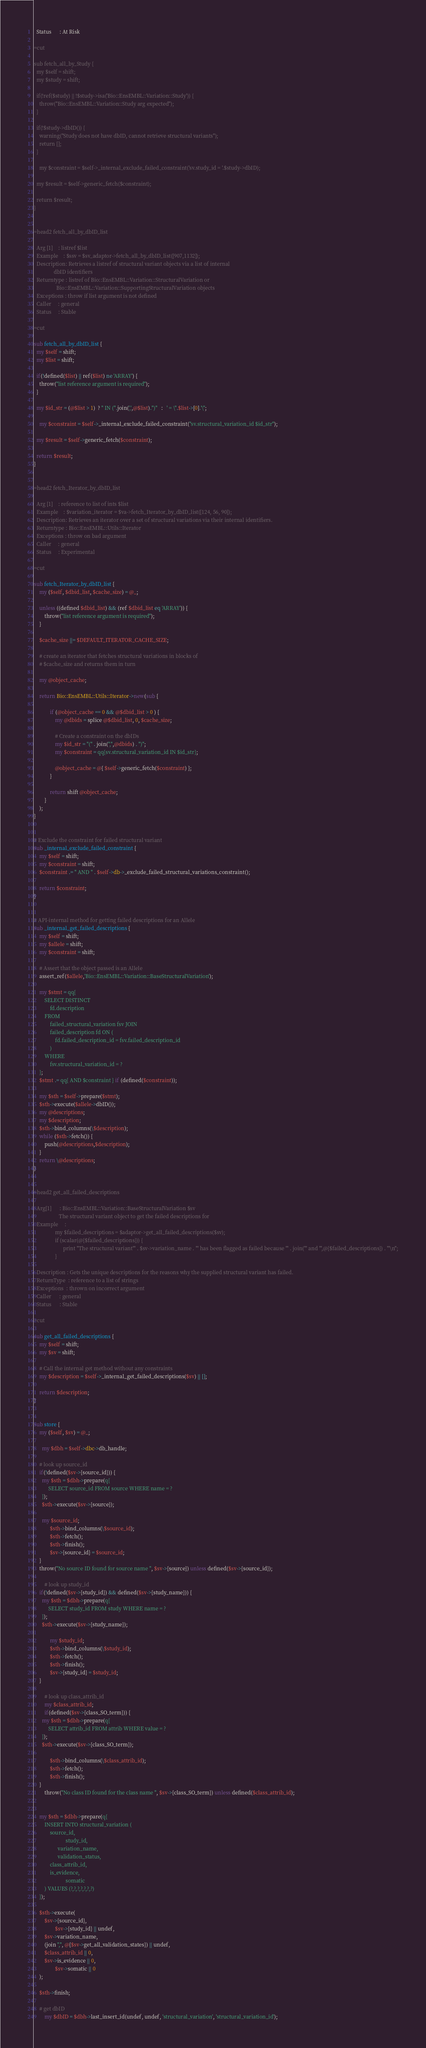Convert code to text. <code><loc_0><loc_0><loc_500><loc_500><_Perl_>  Status      : At Risk

=cut

sub fetch_all_by_Study {
  my $self = shift;
  my $study = shift;

  if(!ref($study) || !$study->isa('Bio::EnsEMBL::Variation::Study')) {
    throw("Bio::EnsEMBL::Variation::Study arg expected");
  }
    
  if(!$study->dbID()) {
    warning("Study does not have dbID, cannot retrieve structural variants");
    return [];
  } 
	
	my $constraint = $self->_internal_exclude_failed_constraint('sv.study_id = '.$study->dbID);
	
  my $result = $self->generic_fetch($constraint);

  return $result;
}


=head2 fetch_all_by_dbID_list

  Arg [1]    : listref $list
  Example    : $ssv = $sv_adaptor->fetch_all_by_dbID_list([907,1132]);
  Description: Retrieves a listref of structural variant objects via a list of internal
               dbID identifiers
  Returntype : listref of Bio::EnsEMBL::Variation::StructuralVariation or
	             Bio::EnsEMBL::Variation::SupportingStructuralVariation objects
  Exceptions : throw if list argument is not defined
  Caller     : general
  Status     : Stable

=cut

sub fetch_all_by_dbID_list {
  my $self = shift;
  my $list = shift;

  if(!defined($list) || ref($list) ne 'ARRAY') {
    throw("list reference argument is required");
  }
  
  my $id_str = (@$list > 1)  ? " IN (".join(',',@$list).")"   :   ' = \''.$list->[0].'\'';
	
	my $constraint = $self->_internal_exclude_failed_constraint("sv.structural_variation_id $id_str");
	
  my $result = $self->generic_fetch($constraint);

  return $result;
}


=head2 fetch_Iterator_by_dbID_list

  Arg [1]    : reference to list of ints $list
  Example    : $variation_iterator = $va->fetch_Iterator_by_dbID_list([124, 56, 90]);
  Description: Retrieves an iterator over a set of structural variations via their internal identifiers.
  Returntype : Bio::EnsEMBL::Utils::Iterator
  Exceptions : throw on bad argument
  Caller     : general
  Status     : Experimental

=cut

sub fetch_Iterator_by_dbID_list {
    my ($self, $dbid_list, $cache_size) = @_;
    
    unless ((defined $dbid_list) && (ref $dbid_list eq 'ARRAY')) {
        throw("list reference argument is required");
    }

    $cache_size ||= $DEFAULT_ITERATOR_CACHE_SIZE;

    # create an iterator that fetches structural variations in blocks of
    # $cache_size and returns them in turn

    my @object_cache;

    return Bio::EnsEMBL::Utils::Iterator->new(sub {

            if (@object_cache == 0 && @$dbid_list > 0 ) {
                my @dbids = splice @$dbid_list, 0, $cache_size;
                
                # Create a constraint on the dbIDs
                my $id_str = "(" . join(",",@dbids) . ")";
                my $constraint = qq{sv.structural_variation_id IN $id_str};
                
                @object_cache = @{ $self->generic_fetch($constraint) };
            }

            return shift @object_cache;
        }
    );
}


# Exclude the constraint for failed structural variant
sub _internal_exclude_failed_constraint {
	my $self = shift;
	my $constraint = shift;
	$constraint .= " AND " . $self->db->_exclude_failed_structural_variations_constraint();
	
	return $constraint;
}


# API-internal method for getting failed descriptions for an Allele
sub _internal_get_failed_descriptions {
    my $self = shift;
    my $allele = shift;
    my $constraint = shift;
    
    # Assert that the object passed is an Allele
    assert_ref($allele,'Bio::EnsEMBL::Variation::BaseStructuralVariation');
    
    my $stmt = qq{
        SELECT DISTINCT
            fd.description
        FROM
            failed_structural_variation fsv JOIN
            failed_description fd ON (
                fd.failed_description_id = fsv.failed_description_id
            )
        WHERE
            fsv.structural_variation_id = ?
    };
    $stmt .= qq{ AND $constraint } if (defined($constraint));
    
    my $sth = $self->prepare($stmt);
    $sth->execute($allele->dbID());
    my @descriptions;
    my $description;
    $sth->bind_columns(\$description);
    while ($sth->fetch()) {
        push(@descriptions,$description);
    }
    return \@descriptions;
}


=head2 get_all_failed_descriptions

  Arg[1]      : Bio::EnsEMBL::Variation::BaseStructuralVariation $sv
	               The structural variant object to get the failed descriptions for
  Example     : 
                my $failed_descriptions = $adaptor->get_all_failed_descriptions($sv);
                if (scalar(@{$failed_descriptions})) {
		              print "The structural variant'" . $sv->variation_name . "' has been flagged as failed because '" . join("' and '",@{$failed_descriptions}) . "'\n";
                }
		
  Description : Gets the unique descriptions for the reasons why the supplied structural variant has failed.
  ReturnType  : reference to a list of strings
  Exceptions  : thrown on incorrect argument
  Caller      : general
  Status      : Stable

=cut

sub get_all_failed_descriptions {
    my $self = shift;
    my $sv = shift;
    
    # Call the internal get method without any constraints
    my $description = $self->_internal_get_failed_descriptions($sv) || [];
    
    return $description;
}


sub store {
    my ($self, $sv) = @_;
    
	  my $dbh = $self->dbc->db_handle;
    
    # look up source_id
    if(!defined($sv->{source_id})) {
      my $sth = $dbh->prepare(q{
           SELECT source_id FROM source WHERE name = ?
      });
      $sth->execute($sv->{source});
        
      my $source_id;
			$sth->bind_columns(\$source_id);
			$sth->fetch();
			$sth->finish();
			$sv->{source_id} = $source_id;
    }
    throw("No source ID found for source name ", $sv->{source}) unless defined($sv->{source_id});
    
		# look up study_id
    if(!defined($sv->{study_id}) && defined($sv->{study_name})) {
      my $sth = $dbh->prepare(q{
           SELECT study_id FROM study WHERE name = ?
      });
      $sth->execute($sv->{study_name});
      
			my $study_id;  
			$sth->bind_columns(\$study_id);
			$sth->fetch();
			$sth->finish();
			$sv->{study_id} = $study_id;
    }
		
		# look up class_attrib_id
		my $class_attrib_id;
		if(defined($sv->{class_SO_term})) {
      my $sth = $dbh->prepare(q{
           SELECT attrib_id FROM attrib WHERE value = ?
      });
      $sth->execute($sv->{class_SO_term});
        
			$sth->bind_columns(\$class_attrib_id);
			$sth->fetch();
			$sth->finish();
    }
		throw("No class ID found for the class name ", $sv->{class_SO_term}) unless defined($class_attrib_id);
		
		
    my $sth = $dbh->prepare(q{
        INSERT INTO structural_variation (
            source_id,
						study_id,
			      variation_name,
			      validation_status,
            class_attrib_id,
            is_evidence,
						somatic
        ) VALUES (?,?,?,?,?,?,?)
    });
    
    $sth->execute(
        $sv->{source_id},
				$sv->{study_id} || undef,
        $sv->variation_name,
        (join ",", @{$sv->get_all_validation_states}) || undef,
        $class_attrib_id || 0,
        $sv->is_evidence || 0,
				$sv->somatic || 0
    );
    
    $sth->finish;
    
    # get dbID
		my $dbID = $dbh->last_insert_id(undef, undef, 'structural_variation', 'structural_variation_id');</code> 